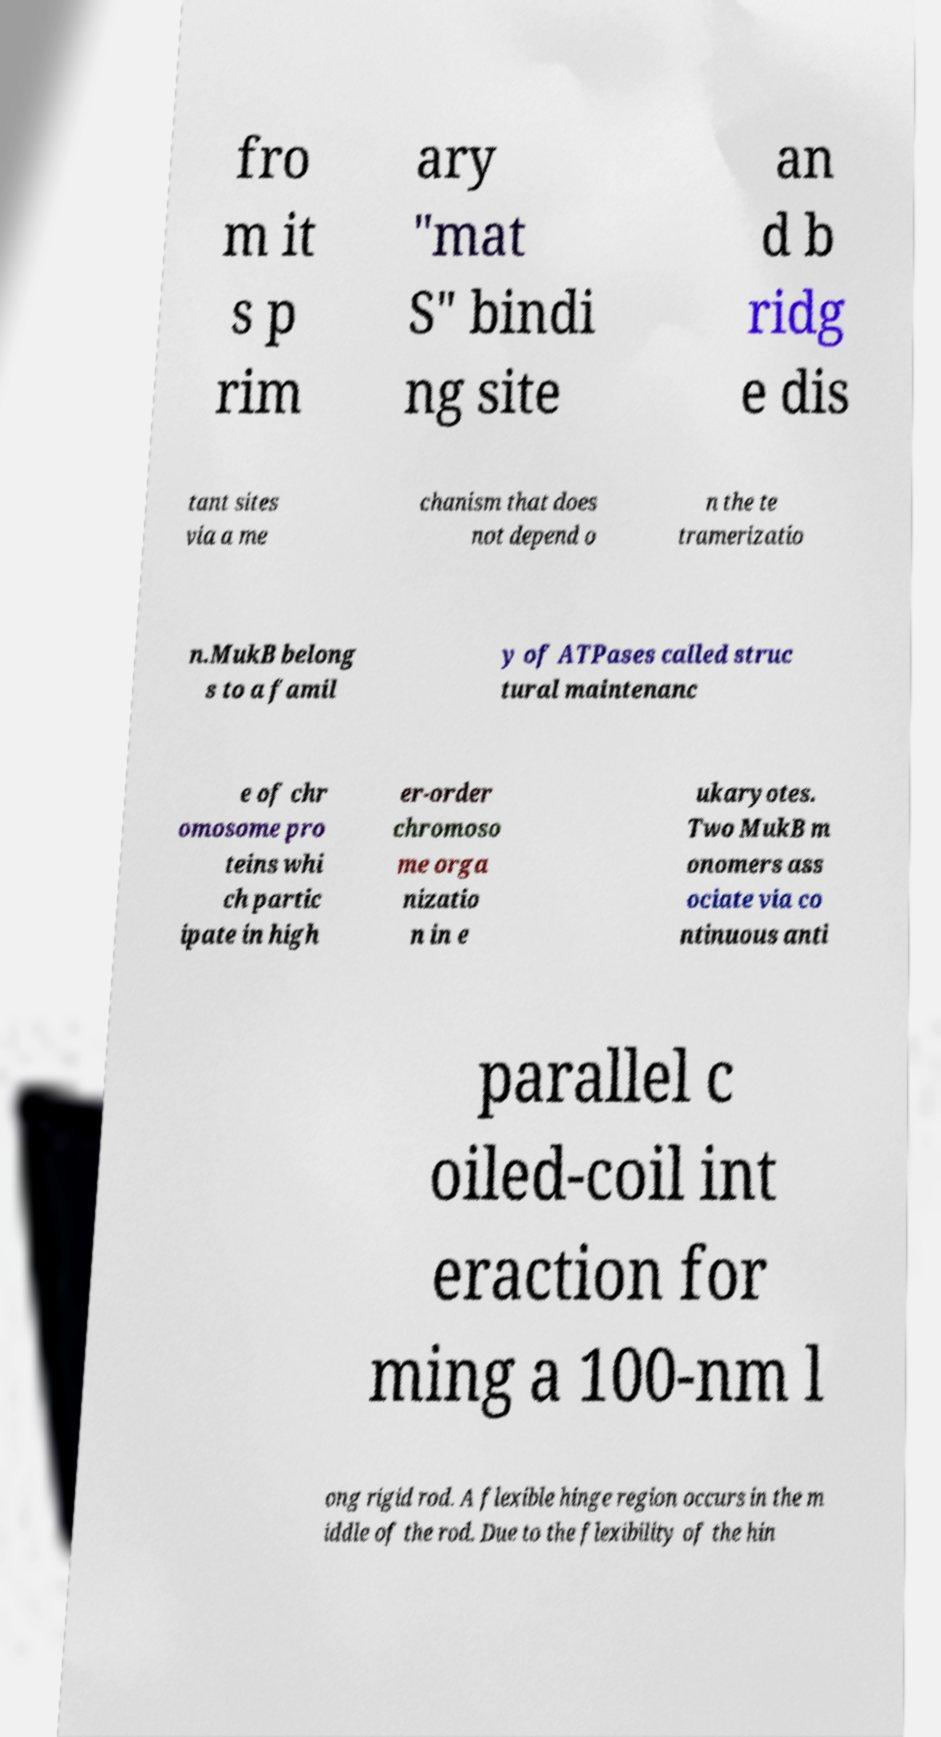There's text embedded in this image that I need extracted. Can you transcribe it verbatim? fro m it s p rim ary "mat S" bindi ng site an d b ridg e dis tant sites via a me chanism that does not depend o n the te tramerizatio n.MukB belong s to a famil y of ATPases called struc tural maintenanc e of chr omosome pro teins whi ch partic ipate in high er-order chromoso me orga nizatio n in e ukaryotes. Two MukB m onomers ass ociate via co ntinuous anti parallel c oiled-coil int eraction for ming a 100-nm l ong rigid rod. A flexible hinge region occurs in the m iddle of the rod. Due to the flexibility of the hin 